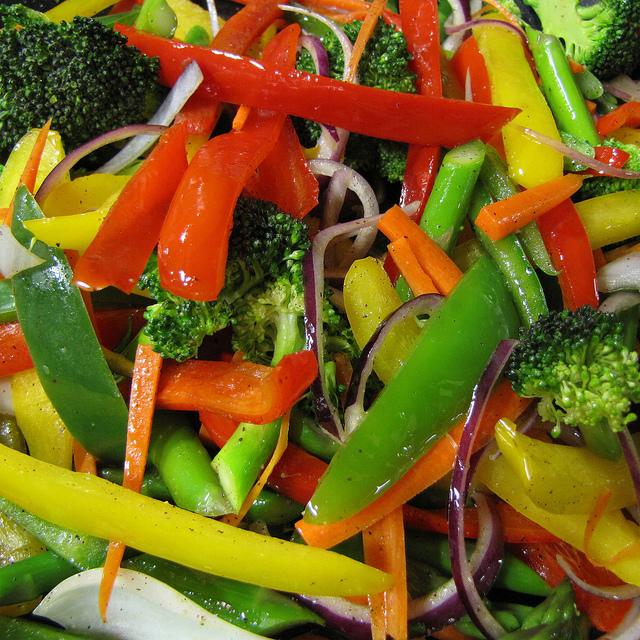Are there carrots in this dish?
Quick response, please. Yes. Is there broccoli in the dish?
Keep it brief. Yes. Are there any purple colored vegetables in the dish?
Write a very short answer. Yes. 